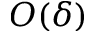Convert formula to latex. <formula><loc_0><loc_0><loc_500><loc_500>O ( \delta )</formula> 